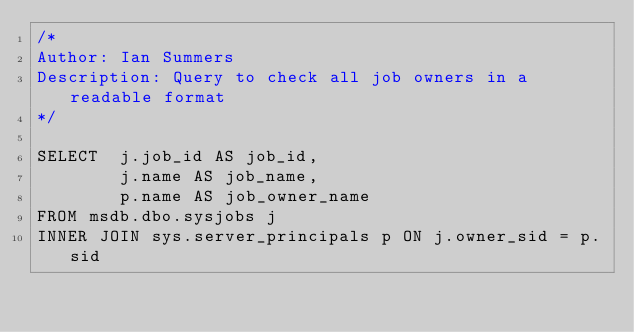<code> <loc_0><loc_0><loc_500><loc_500><_SQL_>/*
Author: Ian Summers
Description: Query to check all job owners in a readable format
*/

SELECT	j.job_id AS job_id,
		j.name AS job_name,
		p.name AS job_owner_name
FROM msdb.dbo.sysjobs j
INNER JOIN sys.server_principals p ON j.owner_sid = p.sid
</code> 